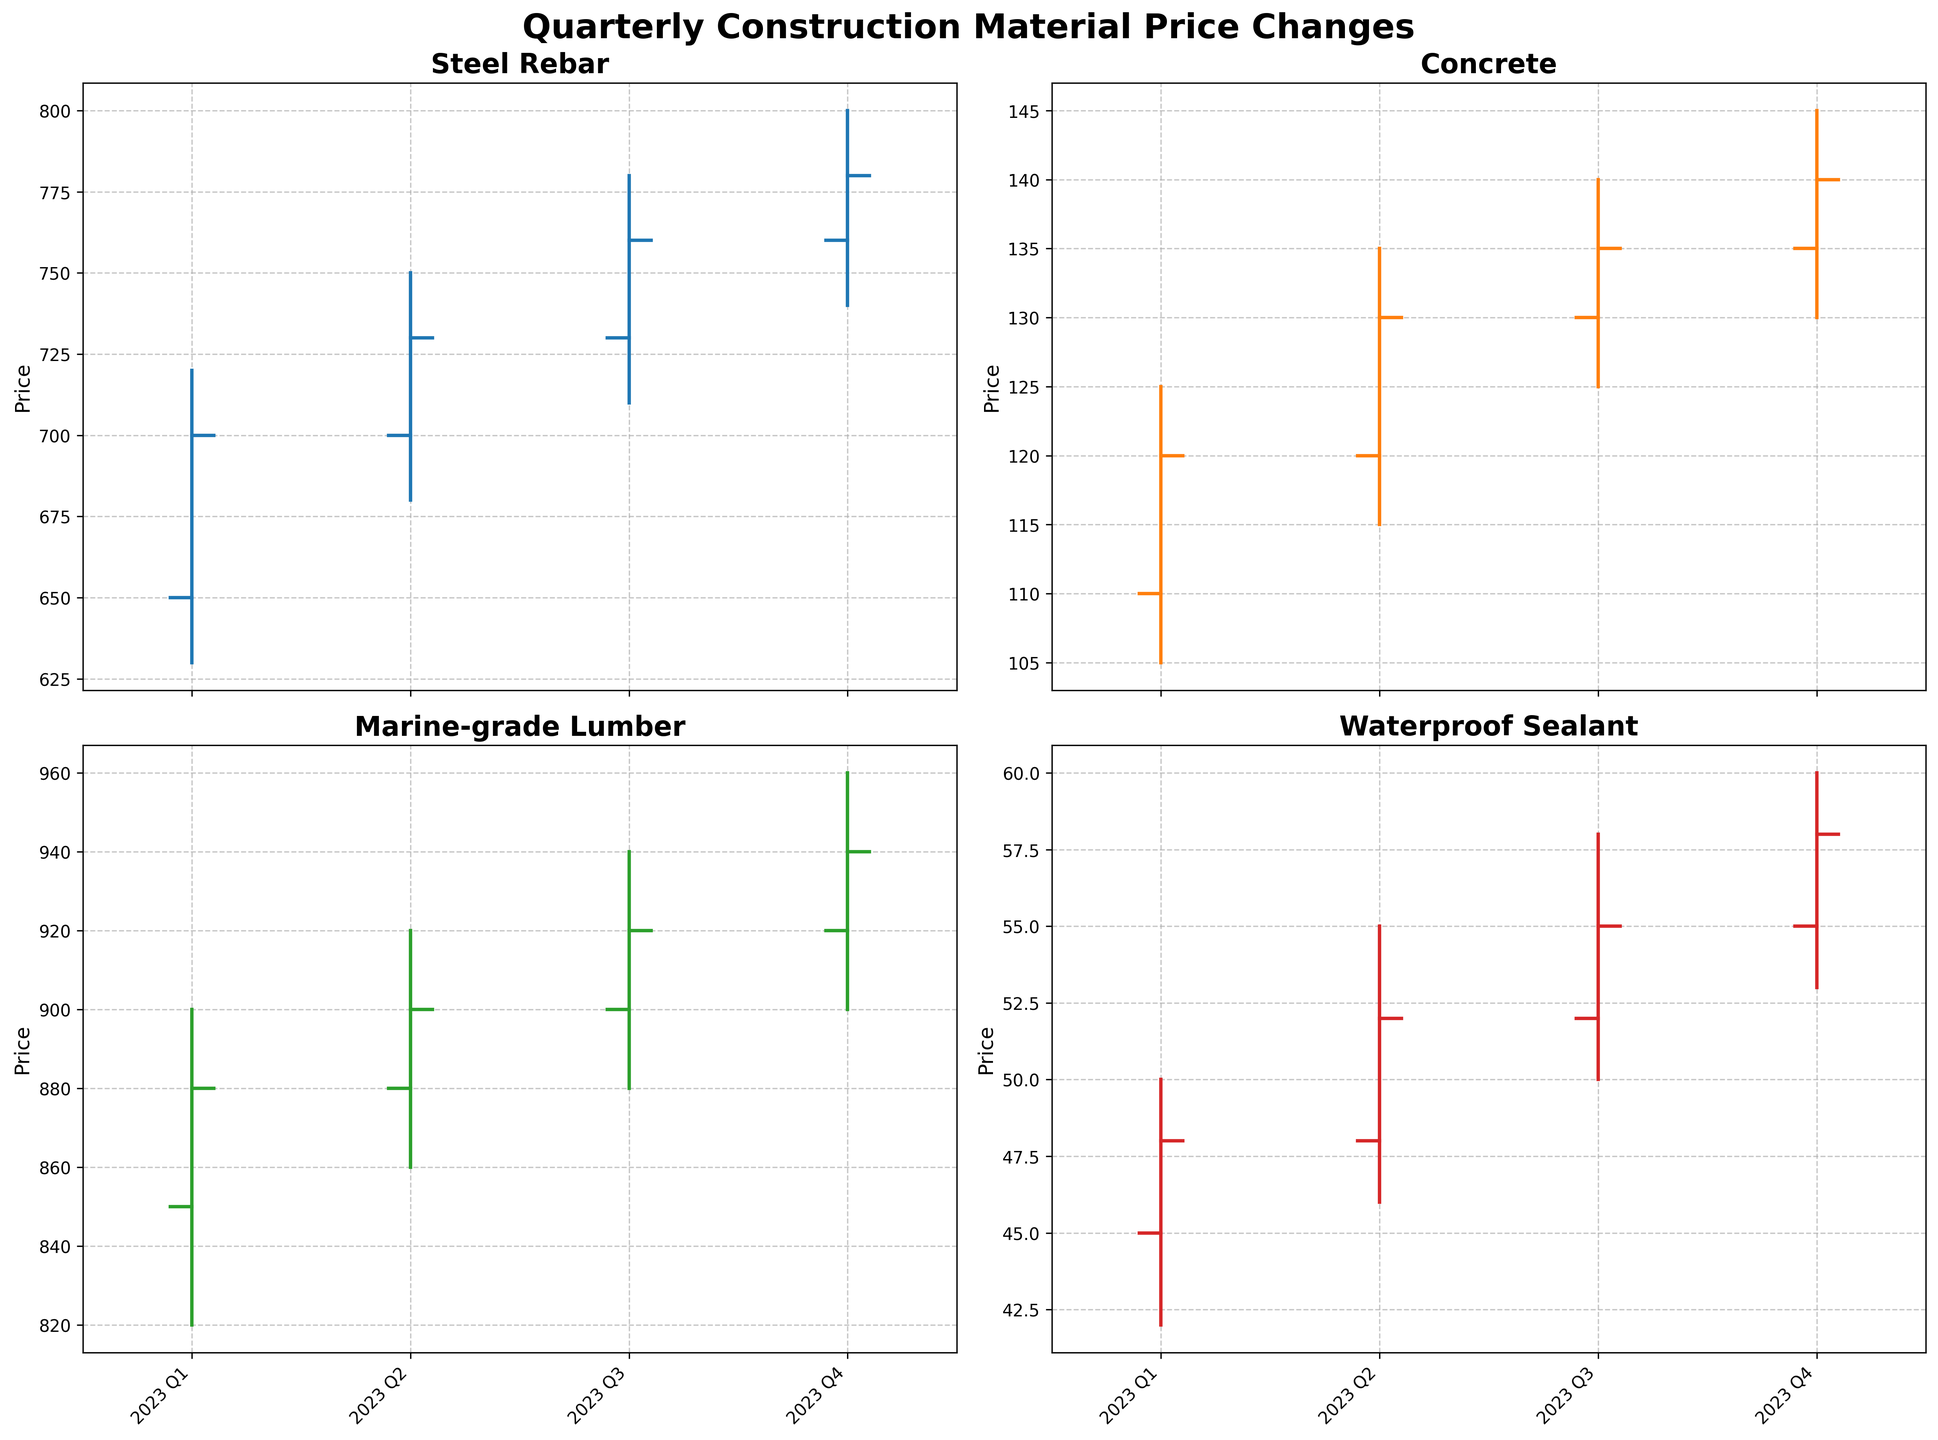What material experienced the highest closing price in 2023 Q4? By looking at the closing prices for each material in 2023 Q4, Marine-grade Lumber has the highest closing price of 940
Answer: Marine-grade Lumber What are the average opening prices of Steel Rebar across all quarters? The opening prices for Steel Rebar are 650, 700, 730, and 760. Adding them up gives 2840, and there are 4 quarters, so the average opening price is 2840 / 4 = 710
Answer: 710 In which quarter did Concrete experience the largest range of prices? To find the price range for Concrete in each quarter, subtract the low price from the high price. For Q1: 125 - 105 = 20, Q2: 135 - 115 = 20, Q3: 140 - 125 = 15, Q4: 145 - 130 = 15. Both Q1 and Q2 have the largest range of 20
Answer: Q1 and Q2 Which quarter saw the highest high price for Waterproof Sealant? By checking the high prices for Waterproof Sealant in each quarter, 50 (Q1), 55 (Q2), 58 (Q3), and 60 (Q4), Q4 has the highest high price of 60
Answer: Q4 How did the closing prices of Steel Rebar change from Q1 to Q4? The closing prices of Steel Rebar from Q1 to Q4 are: 700 (Q1), 730 (Q2), 760 (Q3), and 780 (Q4). Subtracting each consecutive quarter: 730 - 700 = 30, 760 - 730 = 30, 780 - 760 = 20. The overall change is 780 - 700 = 80
Answer: Increased by 80 Which material had the smallest variation in price in 2023 Q3? Calculate the range (high - low) for each material in Q3: Steel Rebar (70), Concrete (15), Marine-grade Lumber (60), Waterproof Sealant (8). Waterproof Sealant has the smallest variation of 8
Answer: Waterproof Sealant What was the difference between the opening and closing prices of Marine-grade Lumber in 2023 Q2? For Marine-grade Lumber in Q2, the opening price is 880 and the closing price is 900. The difference is 900 - 880 = 20
Answer: 20 Compare the closing prices of Concrete in Q1 with its closing price in Q4. Which is higher? In Q1, the closing price of Concrete is 120, and in Q4 it is 140. Comparing these, 140 is higher than 120
Answer: Q4 Which quarter had the highest low price for Steel Rebar? From the data, the low prices for Steel Rebar are 630 (Q1), 680 (Q2), 710 (Q3), and 740 (Q4). Q4 had the highest low price of 740
Answer: Q4 